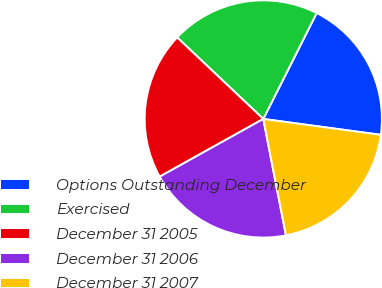Convert chart to OTSL. <chart><loc_0><loc_0><loc_500><loc_500><pie_chart><fcel>Options Outstanding December<fcel>Exercised<fcel>December 31 2005<fcel>December 31 2006<fcel>December 31 2007<nl><fcel>19.71%<fcel>20.37%<fcel>20.15%<fcel>19.97%<fcel>19.8%<nl></chart> 